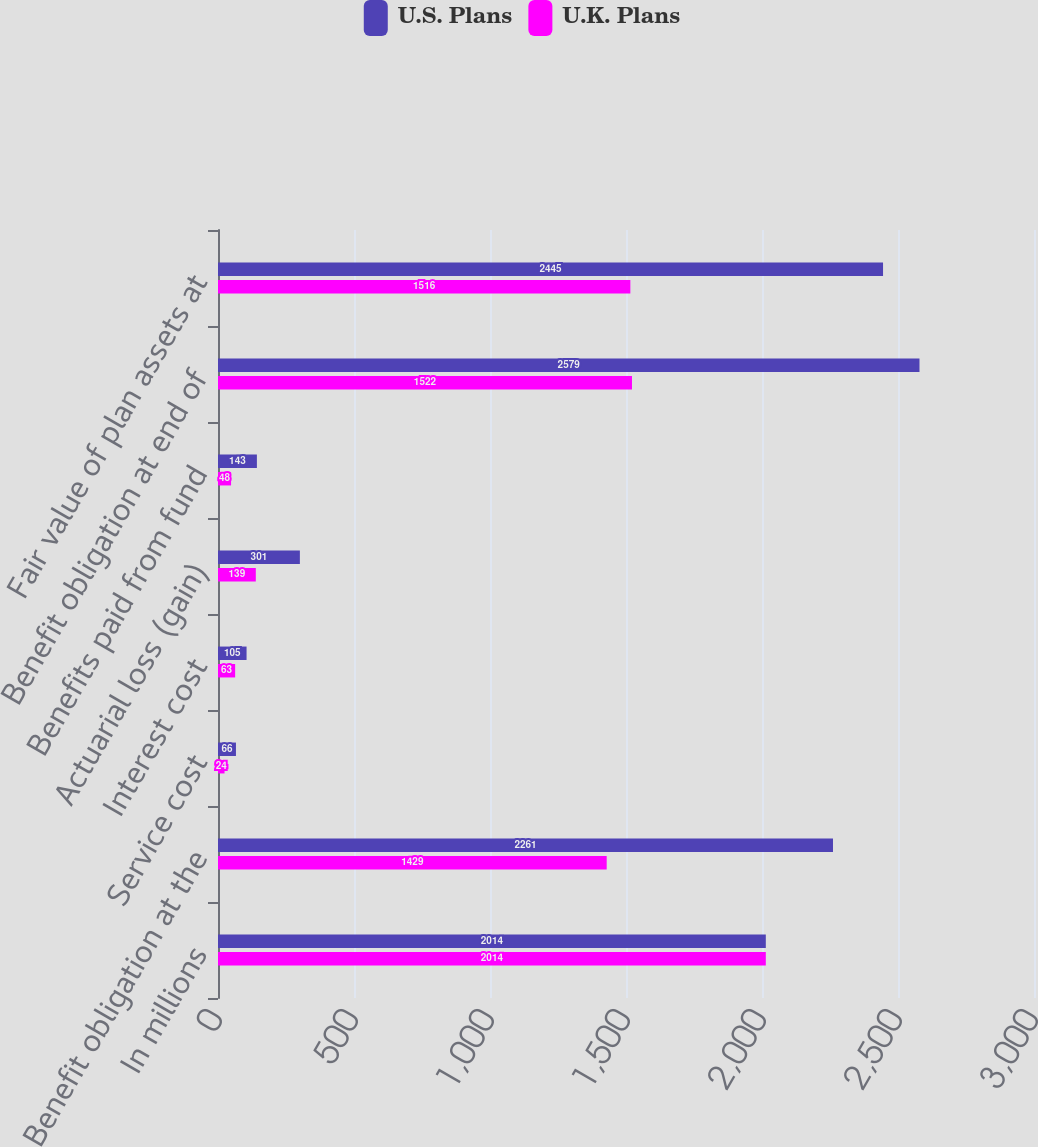Convert chart. <chart><loc_0><loc_0><loc_500><loc_500><stacked_bar_chart><ecel><fcel>In millions<fcel>Benefit obligation at the<fcel>Service cost<fcel>Interest cost<fcel>Actuarial loss (gain)<fcel>Benefits paid from fund<fcel>Benefit obligation at end of<fcel>Fair value of plan assets at<nl><fcel>U.S. Plans<fcel>2014<fcel>2261<fcel>66<fcel>105<fcel>301<fcel>143<fcel>2579<fcel>2445<nl><fcel>U.K. Plans<fcel>2014<fcel>1429<fcel>24<fcel>63<fcel>139<fcel>48<fcel>1522<fcel>1516<nl></chart> 